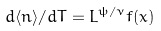<formula> <loc_0><loc_0><loc_500><loc_500>d \langle n \rangle / d T = L ^ { \psi / \nu } f ( x )</formula> 